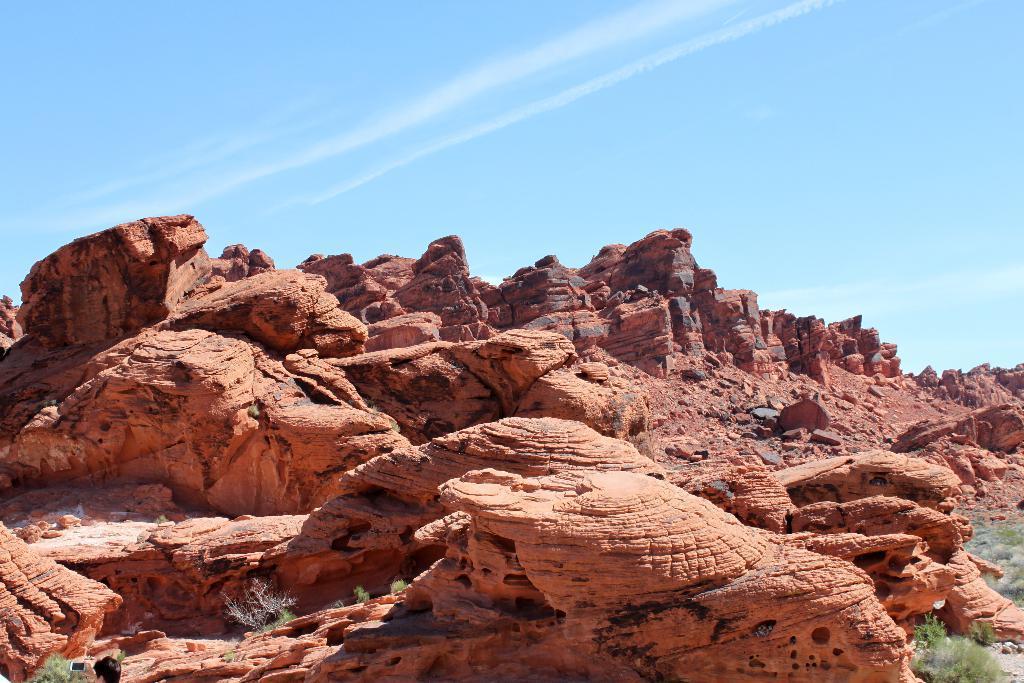Can you describe this image briefly? In this image, we can see some rock hills. We can see some grass. We can see the sky with clouds. 